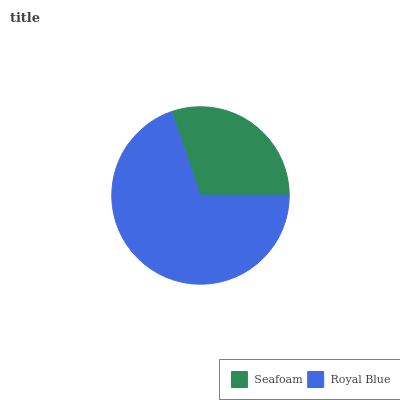Is Seafoam the minimum?
Answer yes or no. Yes. Is Royal Blue the maximum?
Answer yes or no. Yes. Is Royal Blue the minimum?
Answer yes or no. No. Is Royal Blue greater than Seafoam?
Answer yes or no. Yes. Is Seafoam less than Royal Blue?
Answer yes or no. Yes. Is Seafoam greater than Royal Blue?
Answer yes or no. No. Is Royal Blue less than Seafoam?
Answer yes or no. No. Is Royal Blue the high median?
Answer yes or no. Yes. Is Seafoam the low median?
Answer yes or no. Yes. Is Seafoam the high median?
Answer yes or no. No. Is Royal Blue the low median?
Answer yes or no. No. 